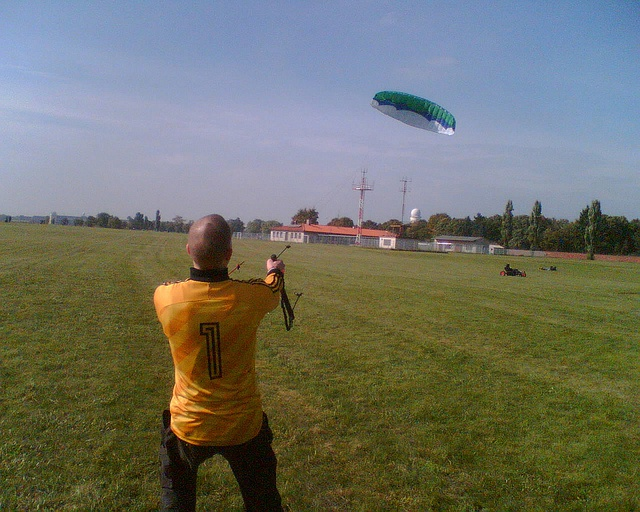Describe the objects in this image and their specific colors. I can see people in darkgray, black, maroon, brown, and olive tones, kite in darkgray, gray, teal, and navy tones, and people in darkgray, black, darkgreen, and olive tones in this image. 